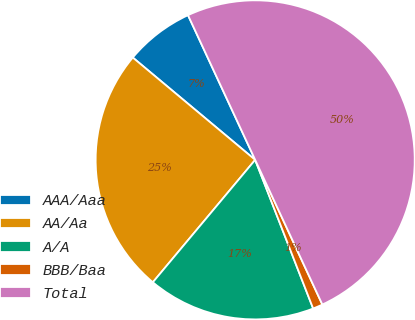Convert chart to OTSL. <chart><loc_0><loc_0><loc_500><loc_500><pie_chart><fcel>AAA/Aaa<fcel>AA/Aa<fcel>A/A<fcel>BBB/Baa<fcel>Total<nl><fcel>7.0%<fcel>25.0%<fcel>17.0%<fcel>1.0%<fcel>50.0%<nl></chart> 